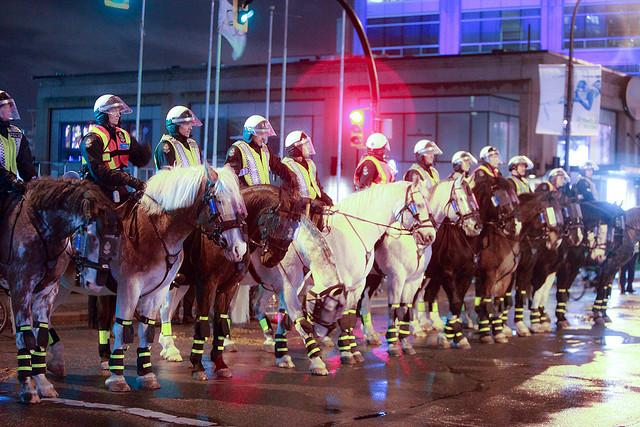What do the officers here observe?

Choices:
A) party
B) horse race
C) candled cake
D) protest protest 